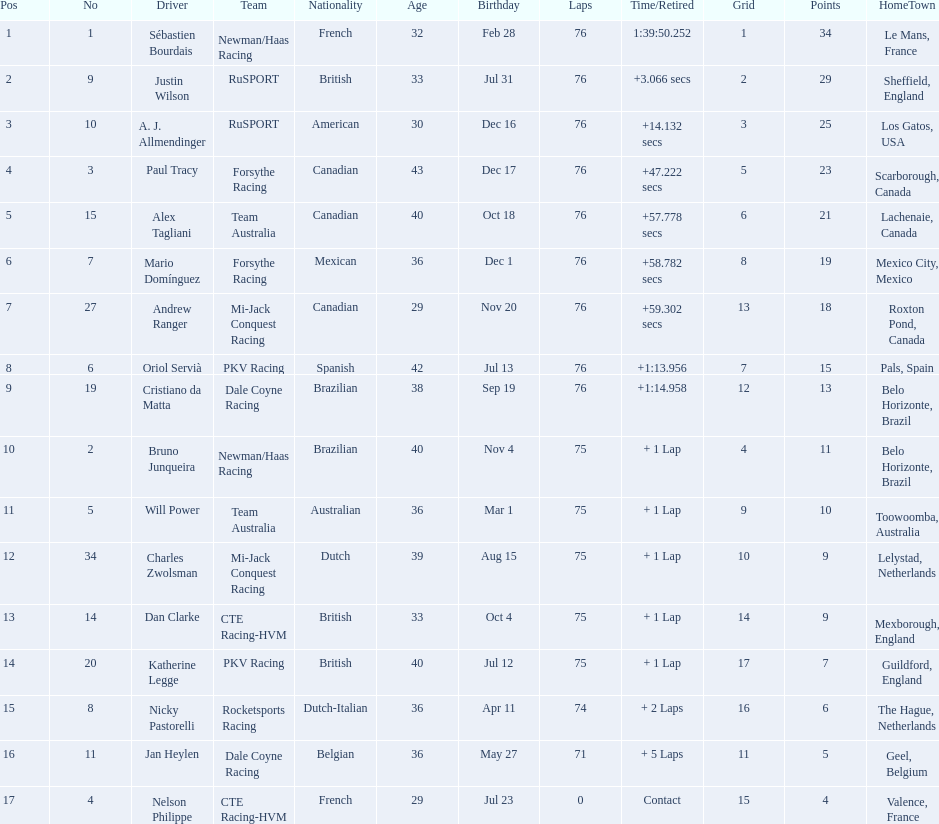Who drove during the 2006 tecate grand prix of monterrey? Sébastien Bourdais, Justin Wilson, A. J. Allmendinger, Paul Tracy, Alex Tagliani, Mario Domínguez, Andrew Ranger, Oriol Servià, Cristiano da Matta, Bruno Junqueira, Will Power, Charles Zwolsman, Dan Clarke, Katherine Legge, Nicky Pastorelli, Jan Heylen, Nelson Philippe. And what were their finishing positions? 1, 2, 3, 4, 5, 6, 7, 8, 9, 10, 11, 12, 13, 14, 15, 16, 17. Who did alex tagliani finish directly behind of? Paul Tracy. 